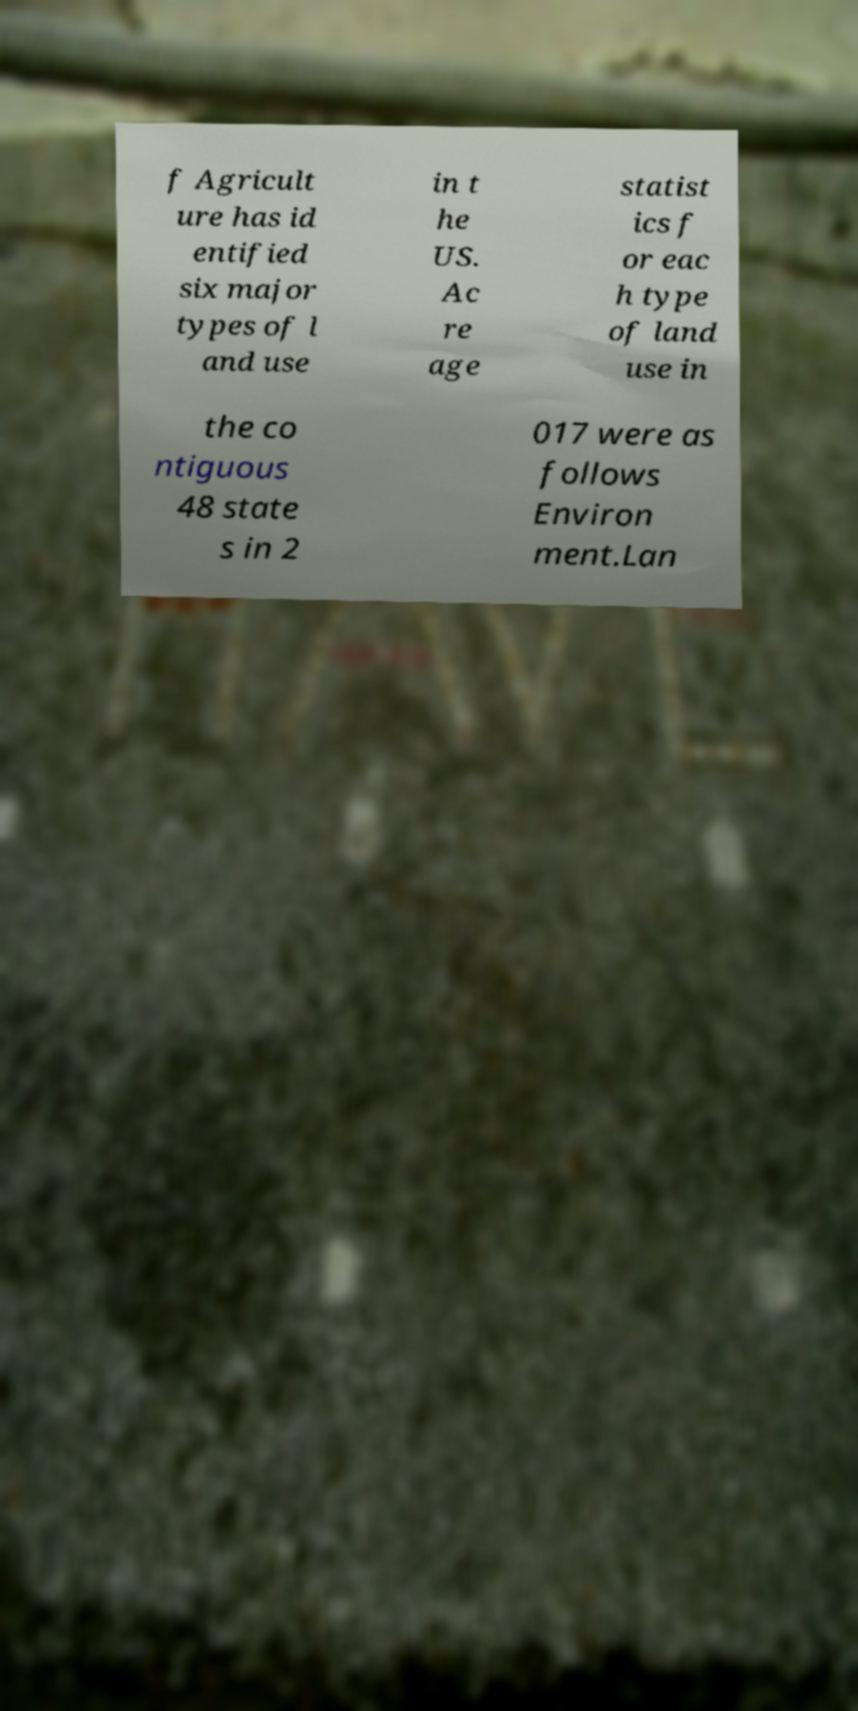Please identify and transcribe the text found in this image. f Agricult ure has id entified six major types of l and use in t he US. Ac re age statist ics f or eac h type of land use in the co ntiguous 48 state s in 2 017 were as follows Environ ment.Lan 